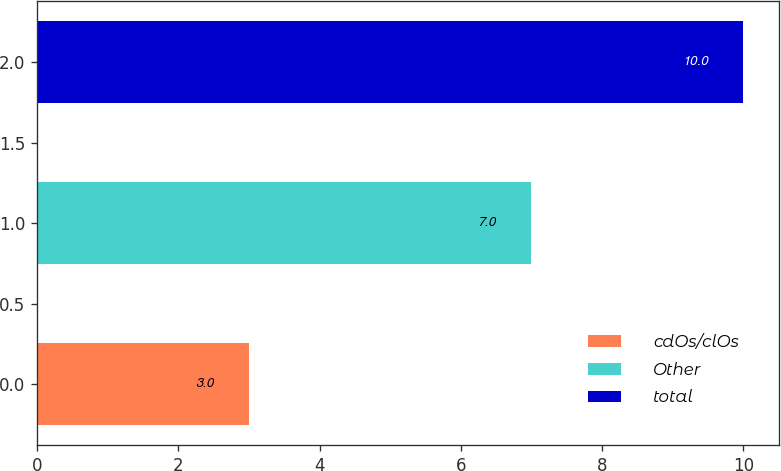Convert chart to OTSL. <chart><loc_0><loc_0><loc_500><loc_500><bar_chart><fcel>cdOs/clOs<fcel>Other<fcel>total<nl><fcel>3<fcel>7<fcel>10<nl></chart> 